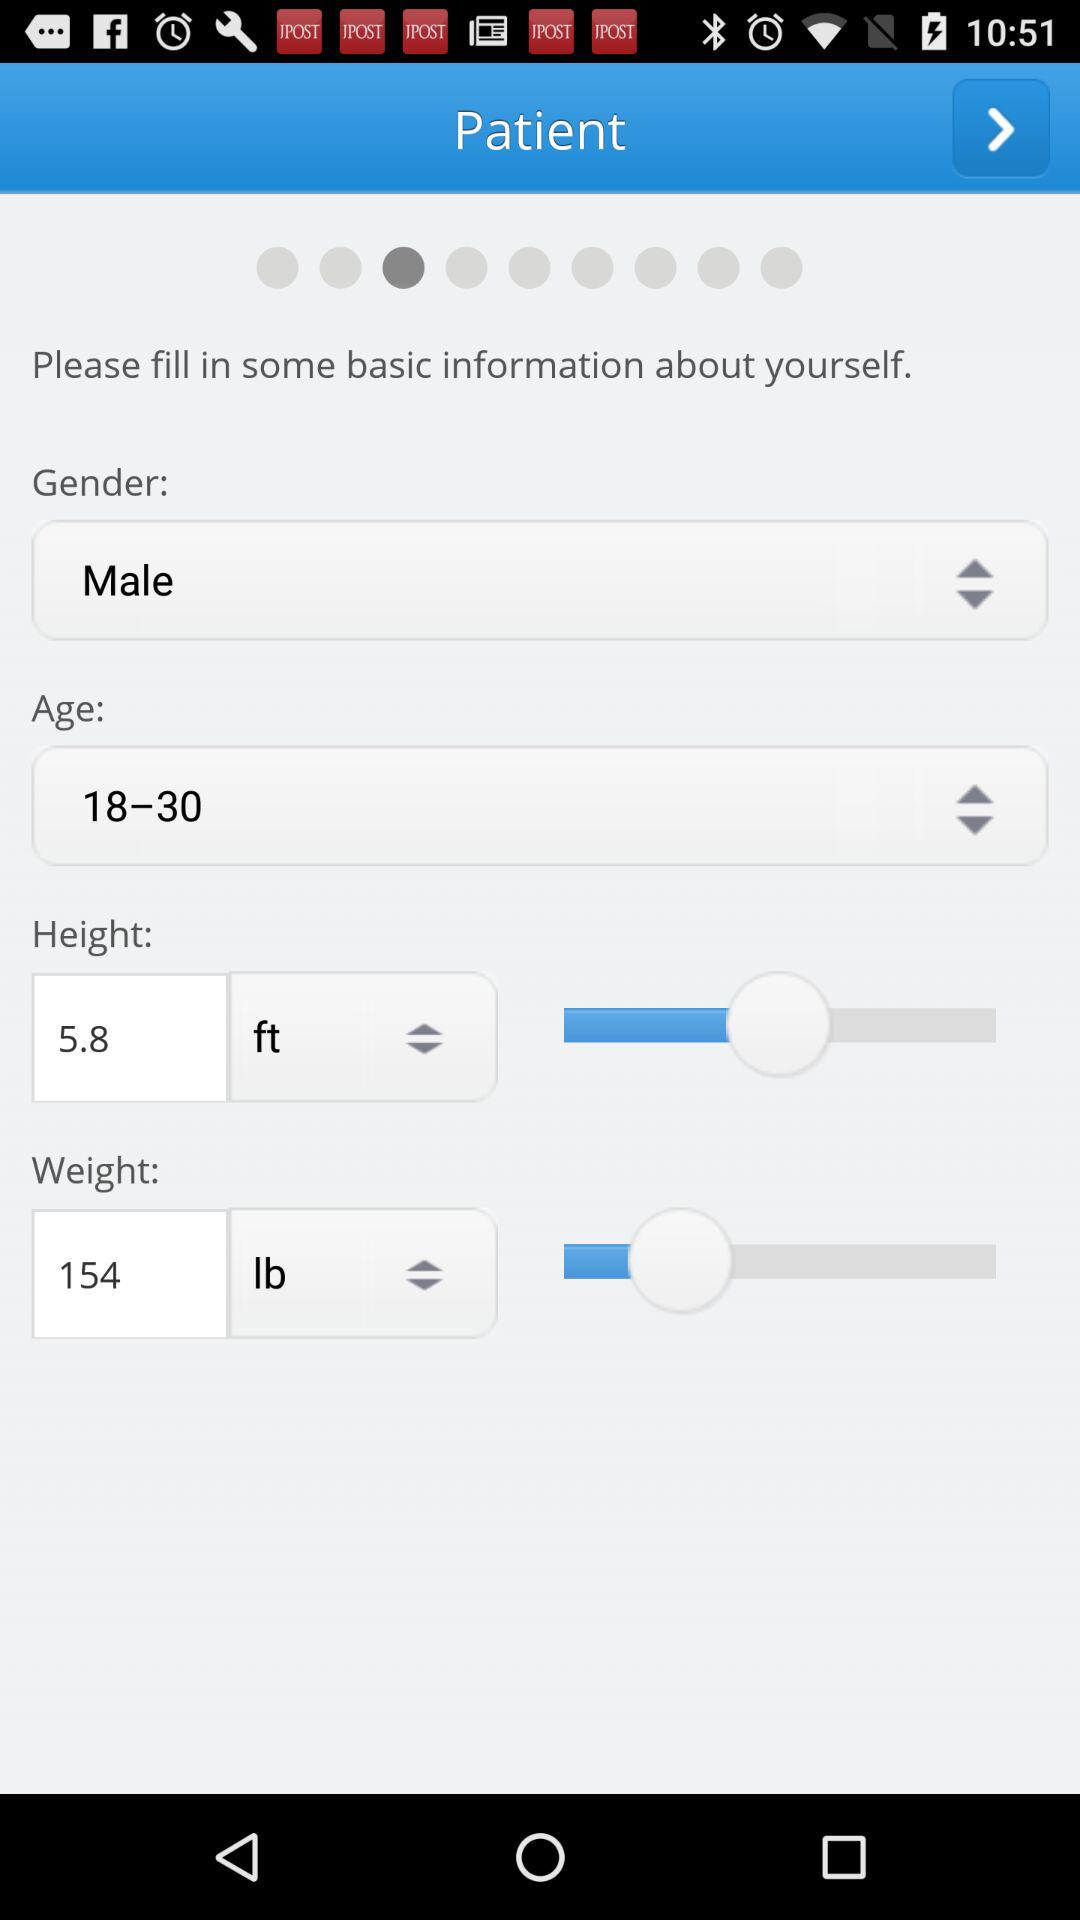What's the gender? The gender is "Male". 